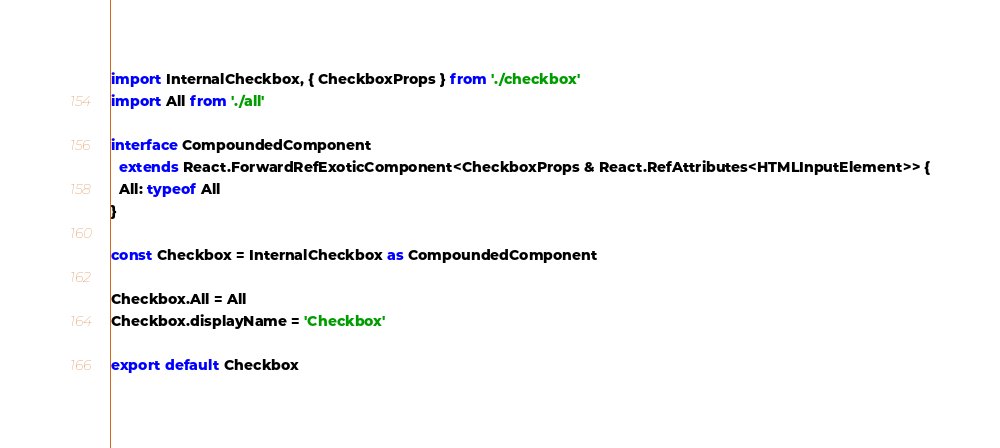Convert code to text. <code><loc_0><loc_0><loc_500><loc_500><_TypeScript_>import InternalCheckbox, { CheckboxProps } from './checkbox'
import All from './all'

interface CompoundedComponent
  extends React.ForwardRefExoticComponent<CheckboxProps & React.RefAttributes<HTMLInputElement>> {
  All: typeof All
}

const Checkbox = InternalCheckbox as CompoundedComponent

Checkbox.All = All
Checkbox.displayName = 'Checkbox'

export default Checkbox
</code> 